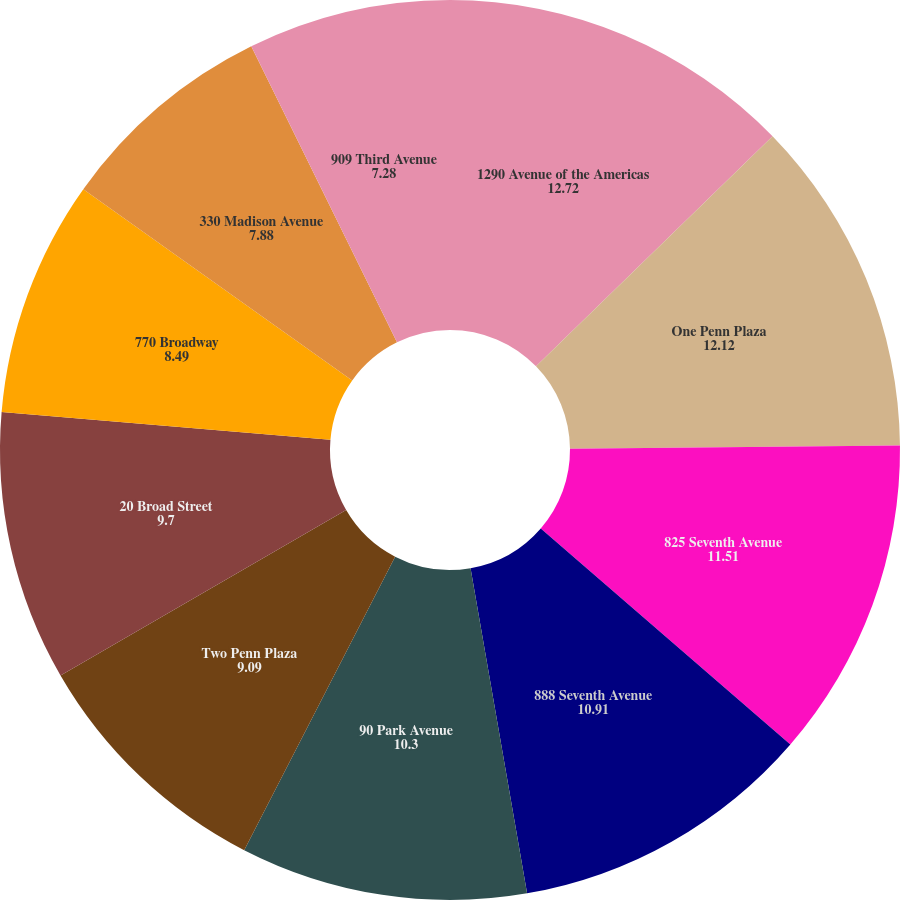Convert chart to OTSL. <chart><loc_0><loc_0><loc_500><loc_500><pie_chart><fcel>1290 Avenue of the Americas<fcel>One Penn Plaza<fcel>825 Seventh Avenue<fcel>888 Seventh Avenue<fcel>90 Park Avenue<fcel>Two Penn Plaza<fcel>20 Broad Street<fcel>770 Broadway<fcel>330 Madison Avenue<fcel>909 Third Avenue<nl><fcel>12.72%<fcel>12.12%<fcel>11.51%<fcel>10.91%<fcel>10.3%<fcel>9.09%<fcel>9.7%<fcel>8.49%<fcel>7.88%<fcel>7.28%<nl></chart> 